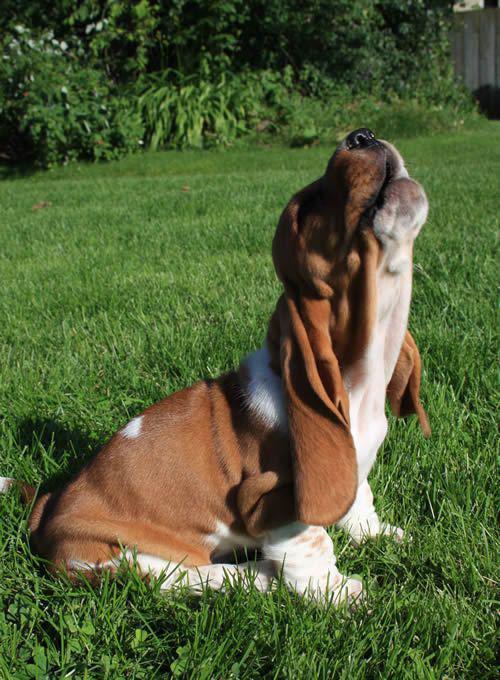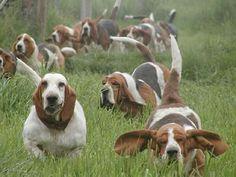The first image is the image on the left, the second image is the image on the right. For the images shown, is this caption "One dog is howling." true? Answer yes or no. Yes. The first image is the image on the left, the second image is the image on the right. For the images shown, is this caption "The left image shows a howling basset hound with its head raised straight up, and the right image includes a basset hound with its ears flying in the wind." true? Answer yes or no. Yes. 